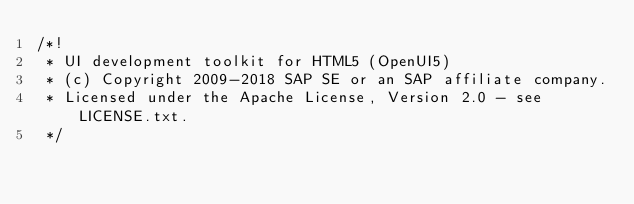<code> <loc_0><loc_0><loc_500><loc_500><_JavaScript_>/*!
 * UI development toolkit for HTML5 (OpenUI5)
 * (c) Copyright 2009-2018 SAP SE or an SAP affiliate company.
 * Licensed under the Apache License, Version 2.0 - see LICENSE.txt.
 */</code> 